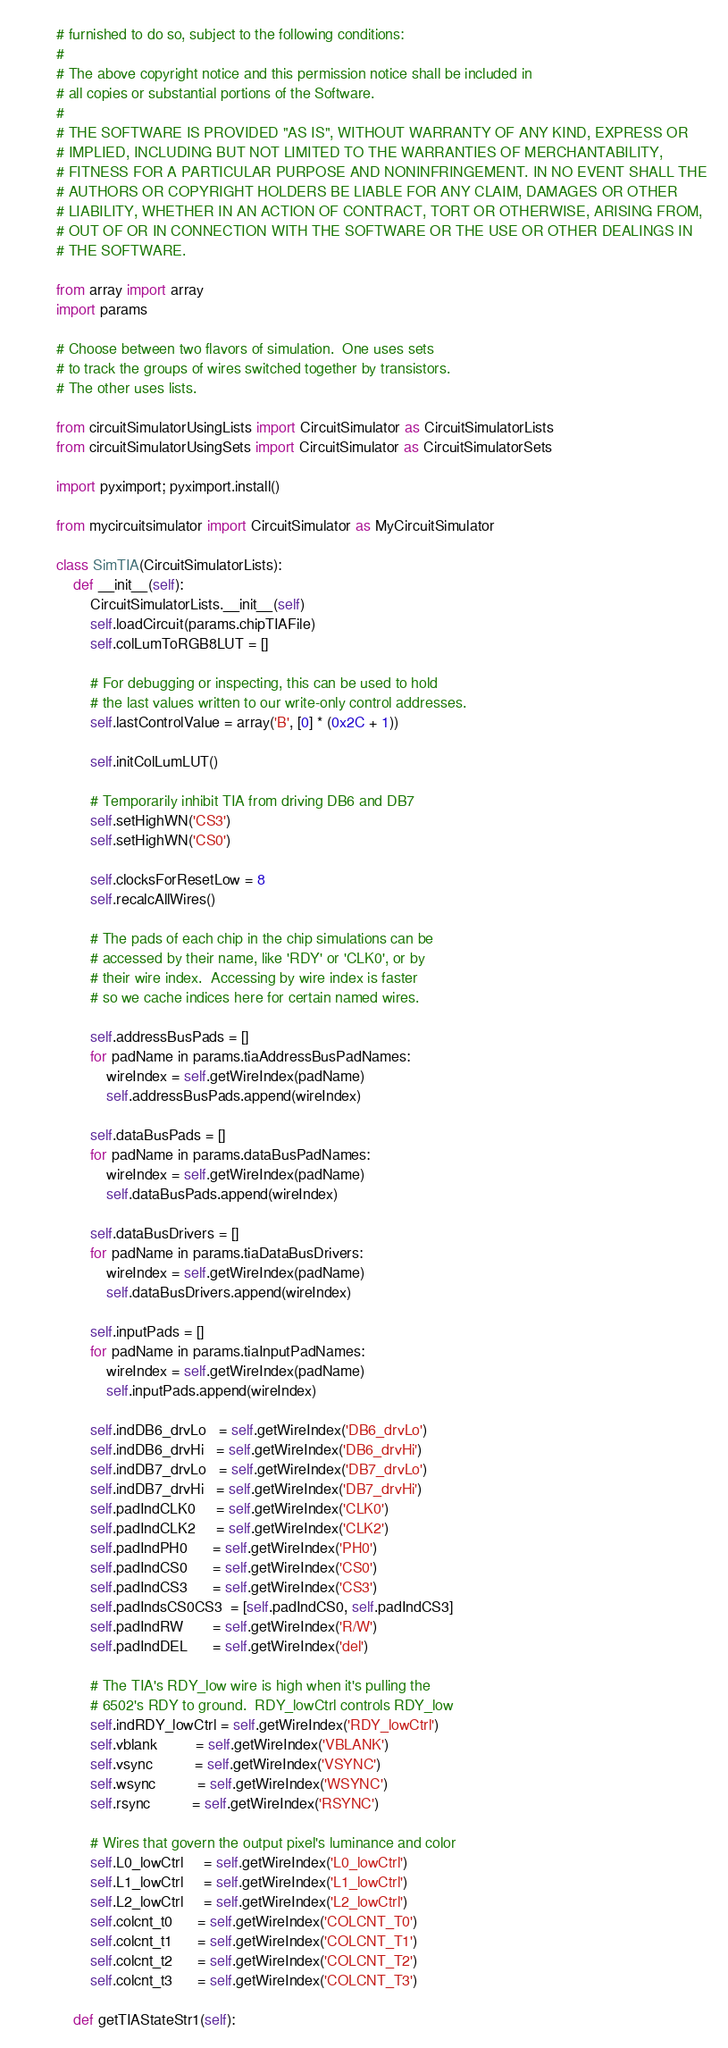Convert code to text. <code><loc_0><loc_0><loc_500><loc_500><_Python_># furnished to do so, subject to the following conditions:
#
# The above copyright notice and this permission notice shall be included in
# all copies or substantial portions of the Software.
#
# THE SOFTWARE IS PROVIDED "AS IS", WITHOUT WARRANTY OF ANY KIND, EXPRESS OR
# IMPLIED, INCLUDING BUT NOT LIMITED TO THE WARRANTIES OF MERCHANTABILITY,
# FITNESS FOR A PARTICULAR PURPOSE AND NONINFRINGEMENT. IN NO EVENT SHALL THE
# AUTHORS OR COPYRIGHT HOLDERS BE LIABLE FOR ANY CLAIM, DAMAGES OR OTHER
# LIABILITY, WHETHER IN AN ACTION OF CONTRACT, TORT OR OTHERWISE, ARISING FROM,
# OUT OF OR IN CONNECTION WITH THE SOFTWARE OR THE USE OR OTHER DEALINGS IN
# THE SOFTWARE.

from array import array
import params

# Choose between two flavors of simulation.  One uses sets
# to track the groups of wires switched together by transistors.
# The other uses lists.

from circuitSimulatorUsingLists import CircuitSimulator as CircuitSimulatorLists
from circuitSimulatorUsingSets import CircuitSimulator as CircuitSimulatorSets

import pyximport; pyximport.install()

from mycircuitsimulator import CircuitSimulator as MyCircuitSimulator

class SimTIA(CircuitSimulatorLists):
    def __init__(self):
        CircuitSimulatorLists.__init__(self)
        self.loadCircuit(params.chipTIAFile)
        self.colLumToRGB8LUT = []

        # For debugging or inspecting, this can be used to hold
        # the last values written to our write-only control addresses.
        self.lastControlValue = array('B', [0] * (0x2C + 1))

        self.initColLumLUT()

        # Temporarily inhibit TIA from driving DB6 and DB7
        self.setHighWN('CS3')
        self.setHighWN('CS0')

        self.clocksForResetLow = 8
        self.recalcAllWires()

        # The pads of each chip in the chip simulations can be
        # accessed by their name, like 'RDY' or 'CLK0', or by
        # their wire index.  Accessing by wire index is faster
        # so we cache indices here for certain named wires.

        self.addressBusPads = []
        for padName in params.tiaAddressBusPadNames:
            wireIndex = self.getWireIndex(padName)
            self.addressBusPads.append(wireIndex)

        self.dataBusPads = []
        for padName in params.dataBusPadNames:
            wireIndex = self.getWireIndex(padName)
            self.dataBusPads.append(wireIndex)

        self.dataBusDrivers = []
        for padName in params.tiaDataBusDrivers:
            wireIndex = self.getWireIndex(padName)
            self.dataBusDrivers.append(wireIndex)

        self.inputPads = []
        for padName in params.tiaInputPadNames:
            wireIndex = self.getWireIndex(padName)
            self.inputPads.append(wireIndex)

        self.indDB6_drvLo   = self.getWireIndex('DB6_drvLo')
        self.indDB6_drvHi   = self.getWireIndex('DB6_drvHi')
        self.indDB7_drvLo   = self.getWireIndex('DB7_drvLo')
        self.indDB7_drvHi   = self.getWireIndex('DB7_drvHi')
        self.padIndCLK0     = self.getWireIndex('CLK0')
        self.padIndCLK2     = self.getWireIndex('CLK2')
        self.padIndPH0      = self.getWireIndex('PH0')
        self.padIndCS0      = self.getWireIndex('CS0')
        self.padIndCS3      = self.getWireIndex('CS3')
        self.padIndsCS0CS3  = [self.padIndCS0, self.padIndCS3]
        self.padIndRW       = self.getWireIndex('R/W')
        self.padIndDEL      = self.getWireIndex('del')

        # The TIA's RDY_low wire is high when it's pulling the
        # 6502's RDY to ground.  RDY_lowCtrl controls RDY_low
        self.indRDY_lowCtrl = self.getWireIndex('RDY_lowCtrl')
        self.vblank         = self.getWireIndex('VBLANK')
        self.vsync          = self.getWireIndex('VSYNC')
        self.wsync          = self.getWireIndex('WSYNC')
        self.rsync          = self.getWireIndex('RSYNC')

        # Wires that govern the output pixel's luminance and color
        self.L0_lowCtrl     = self.getWireIndex('L0_lowCtrl')
        self.L1_lowCtrl     = self.getWireIndex('L1_lowCtrl')
        self.L2_lowCtrl     = self.getWireIndex('L2_lowCtrl')
        self.colcnt_t0      = self.getWireIndex('COLCNT_T0')
        self.colcnt_t1      = self.getWireIndex('COLCNT_T1')
        self.colcnt_t2      = self.getWireIndex('COLCNT_T2')
        self.colcnt_t3      = self.getWireIndex('COLCNT_T3')

    def getTIAStateStr1(self):</code> 